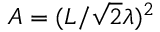Convert formula to latex. <formula><loc_0><loc_0><loc_500><loc_500>A = ( L / \sqrt { 2 } \lambda ) ^ { 2 }</formula> 